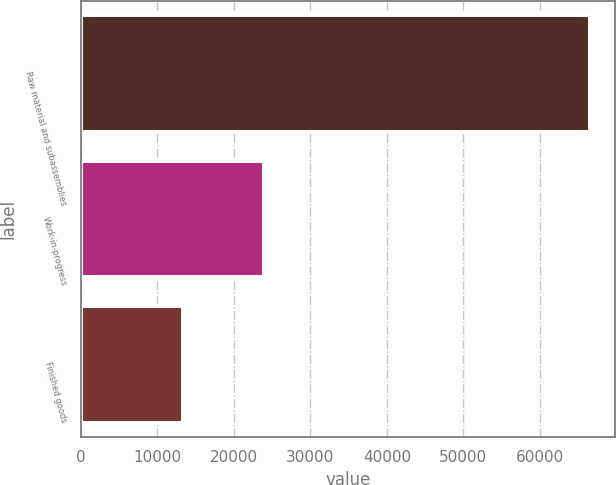Convert chart. <chart><loc_0><loc_0><loc_500><loc_500><bar_chart><fcel>Raw material and subassemblies<fcel>Work-in-progress<fcel>Finished goods<nl><fcel>66553<fcel>23994<fcel>13290<nl></chart> 